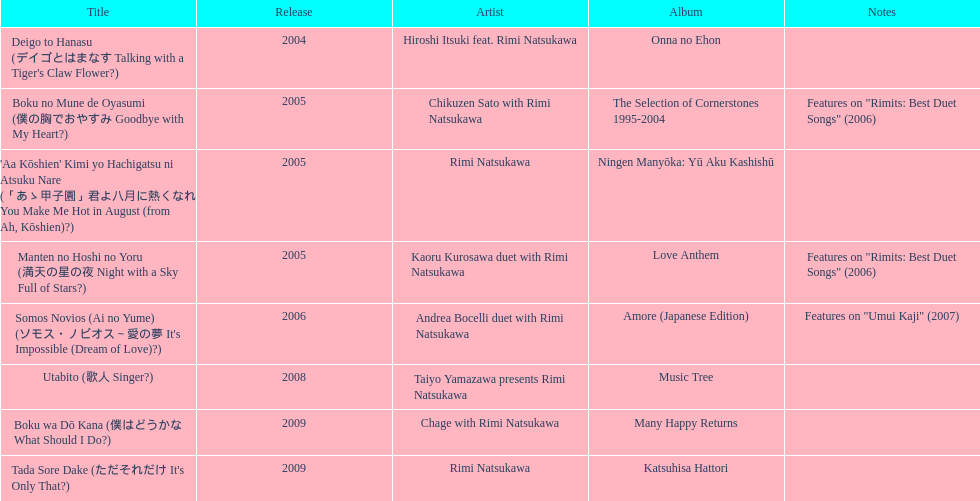How many titles are attributed to just one artist? 2. 